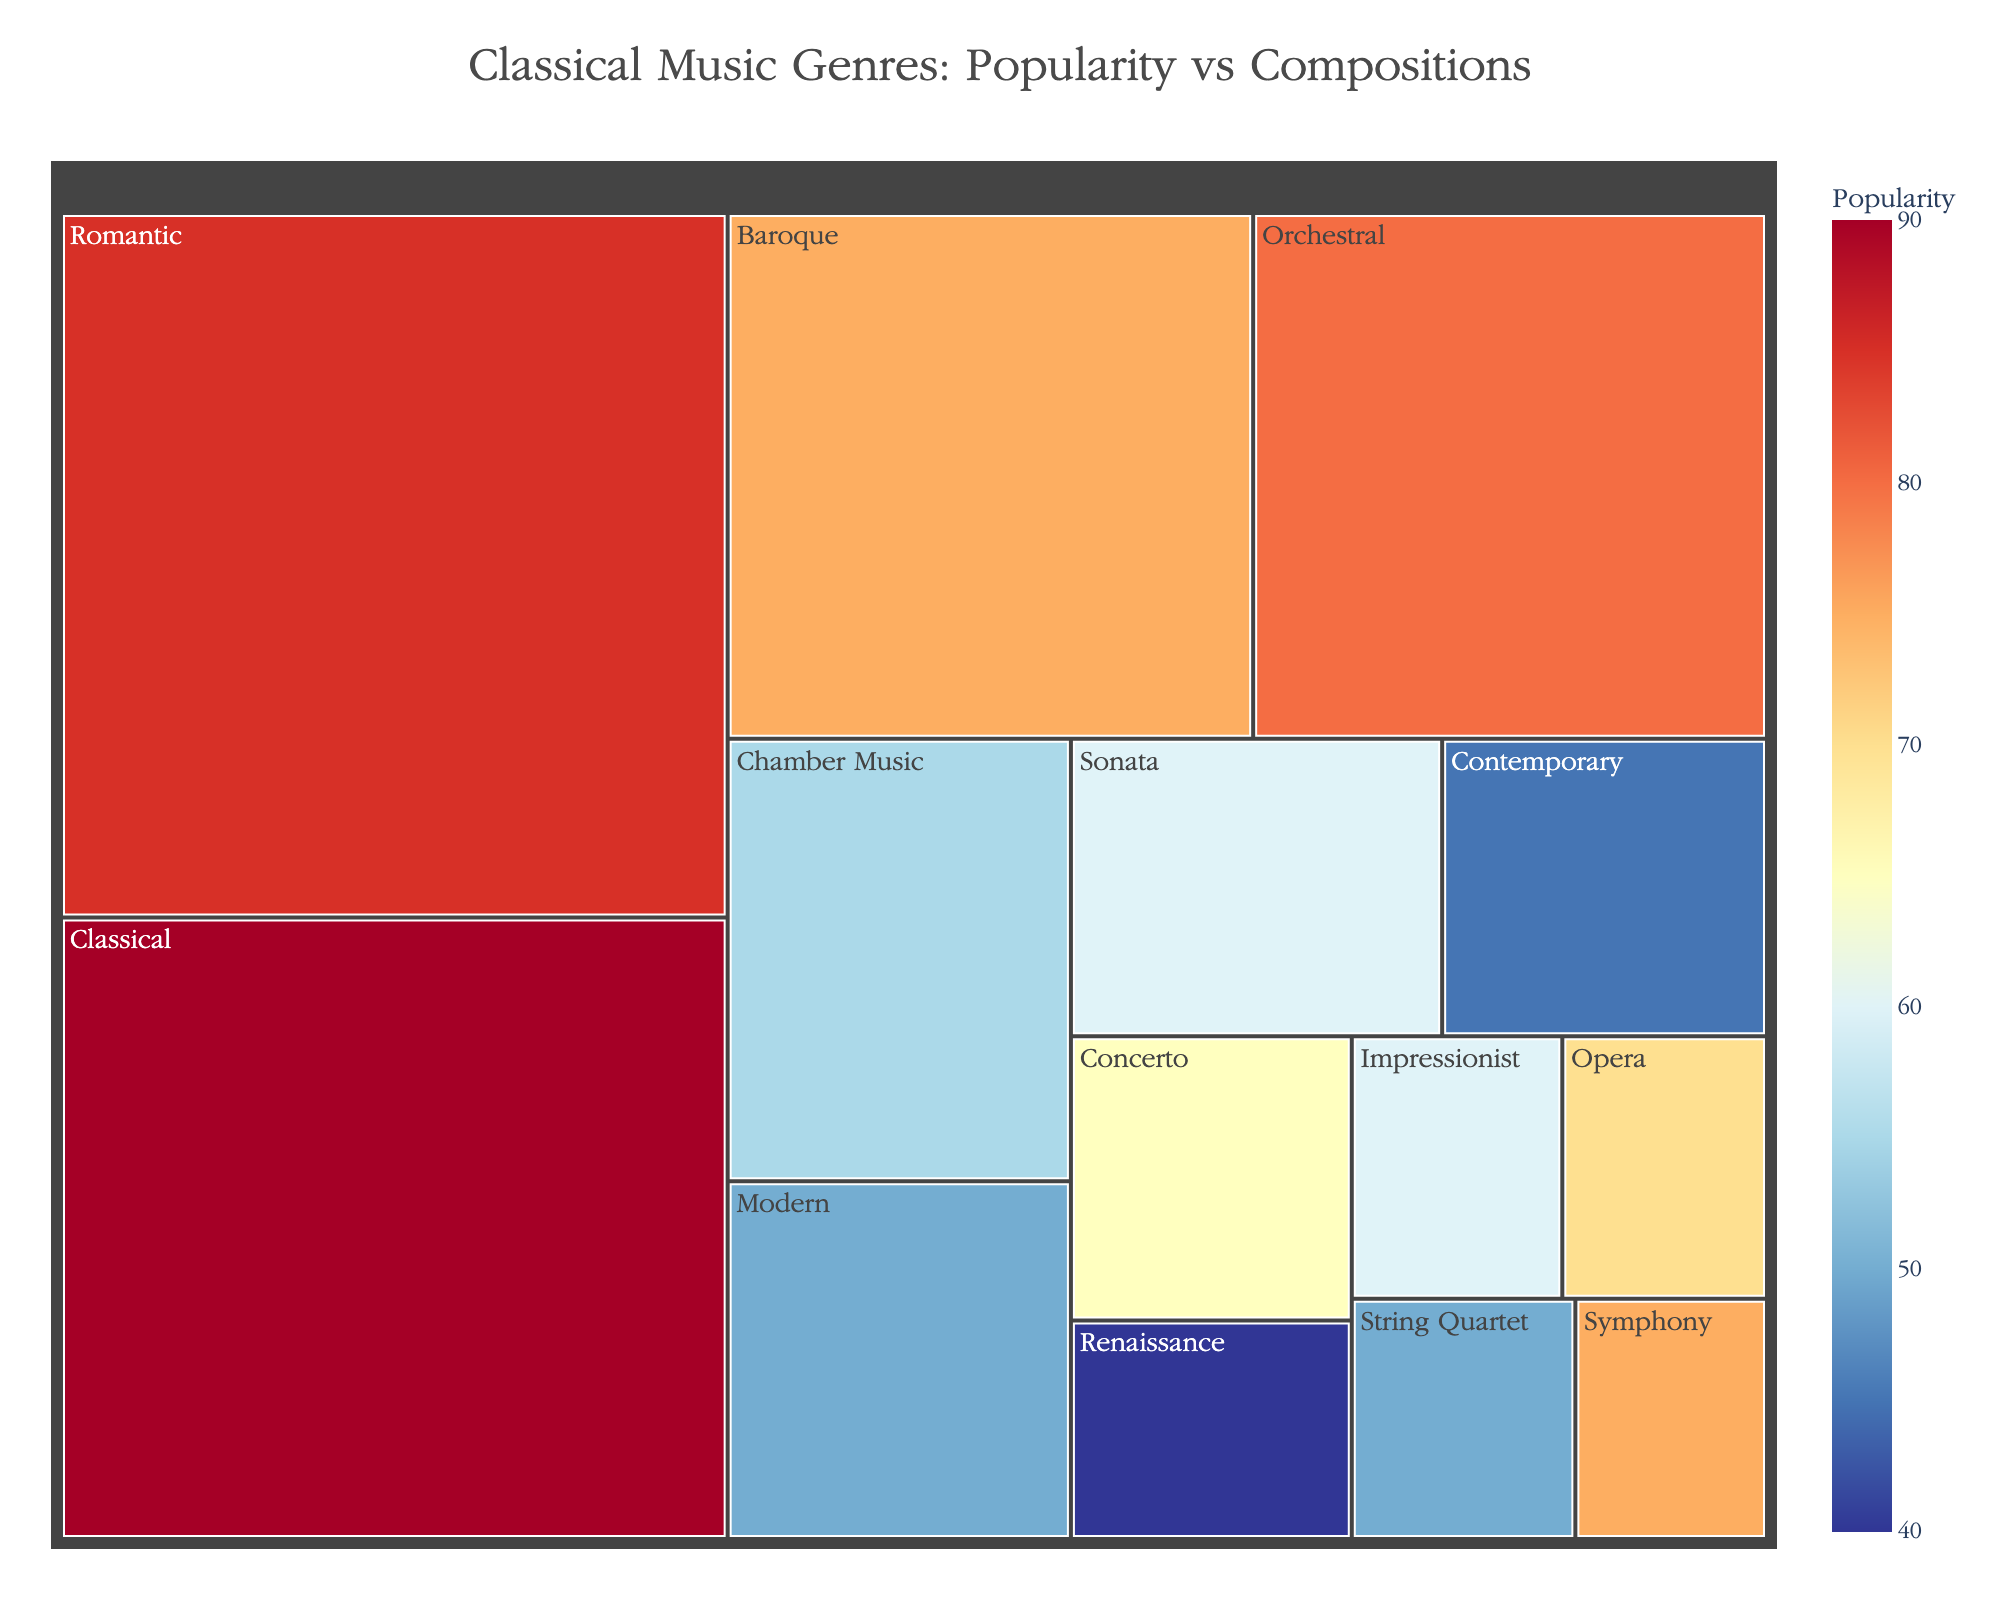How many genres are represented in the treemap? Count the number of individual genres labeled in the visual representation.
Answer: 14 Which genre has the highest popularity? Look at the popularity values indicated by the color scale and find the genre with the highest value.
Answer: Classical What is the total number of compositions for the genres with the highest popularity? Refer to the hover data for the genre with the highest popularity and retrieve the compositions value.
Answer: 15000 How does the number of compositions in the Baroque genre compare to the Romantic genre? Retrieve the compositions values for both genres from the hover data and compare them.
Answer: Baroque: 12000, Romantic: 18000; Romantic has more compositions Which two genres have the closest popularity values? Examine the color shades and popularity values of all genres, finding the two genres closest in value.
Answer: Concerto and Impressionist What is the average popularity of the genres with fewer than 5000 compositions each? Identify the genres with compositions under 5000, then calculate the average of their popularity values. Renaissance (40), Opera (70), Symphony (75), String Quartet (50); (40 + 70 + 75 + 50) / 4
Answer: 58.75 Between Symphony and Chamber Music, which genre has more compositions and by how much? Retrieve the compositions values for Symphony and Chamber Music from the hover data, then subtract to find the difference. Symphony: 2000, Chamber Music: 9000; 9000 - 2000 = 7000 more compositions
Answer: Chamber Music by 7000 Identify a genre with a popularity between 45 and 50. Reference the color scale and hover data to find a genre with a popularity value within the specified range.
Answer: Contemporary Which genre displays the largest visual area on the treemap? Find the genre that occupies the most space in the treemap, indicating a higher TotalValue.
Answer: Romantic How does the TotalValue of the Modern genre compare to the Impressionist genre? Calculate the TotalValue for both genres (Multiply Popularity by Compositions) and compare them. Modern: 50 * 8000 = 400000; Impressionist: 60 * 3000 = 180000; Modern's TotalValue is higher.
Answer: Modern: 400000, Impressionist: 180000 